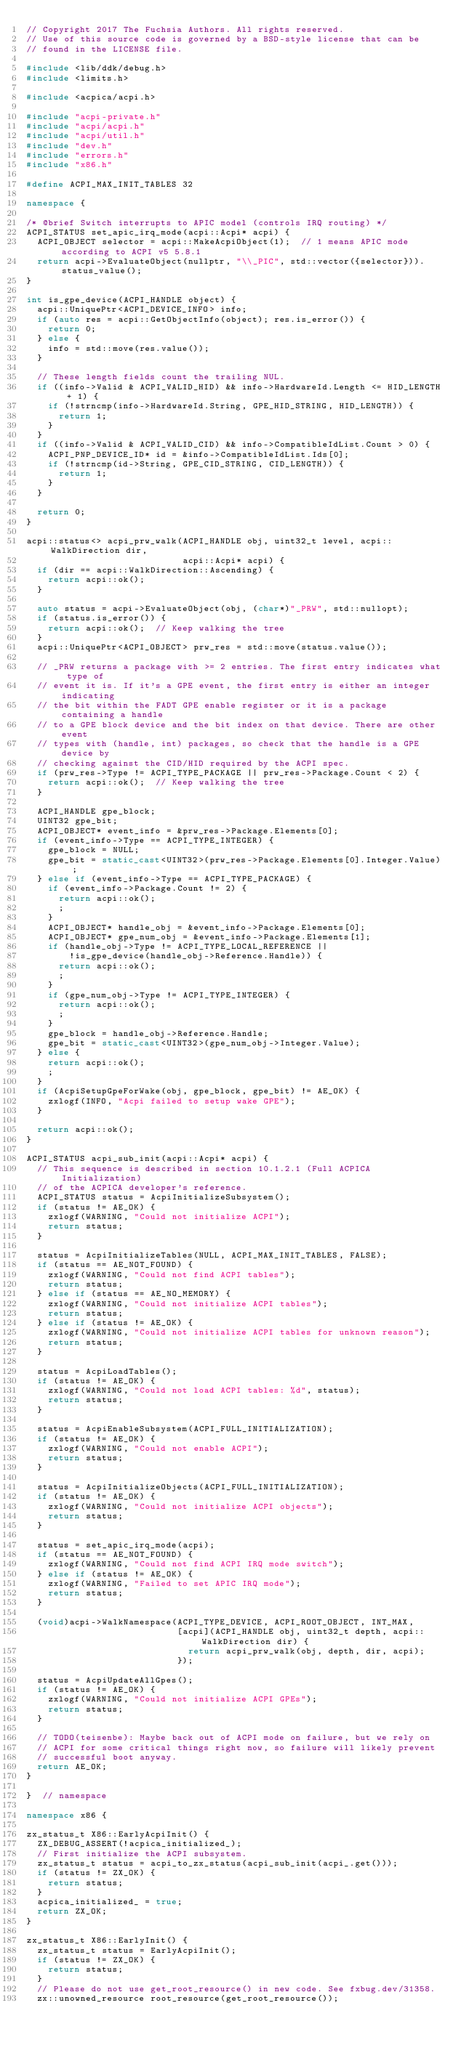Convert code to text. <code><loc_0><loc_0><loc_500><loc_500><_C++_>// Copyright 2017 The Fuchsia Authors. All rights reserved.
// Use of this source code is governed by a BSD-style license that can be
// found in the LICENSE file.

#include <lib/ddk/debug.h>
#include <limits.h>

#include <acpica/acpi.h>

#include "acpi-private.h"
#include "acpi/acpi.h"
#include "acpi/util.h"
#include "dev.h"
#include "errors.h"
#include "x86.h"

#define ACPI_MAX_INIT_TABLES 32

namespace {

/* @brief Switch interrupts to APIC model (controls IRQ routing) */
ACPI_STATUS set_apic_irq_mode(acpi::Acpi* acpi) {
  ACPI_OBJECT selector = acpi::MakeAcpiObject(1);  // 1 means APIC mode according to ACPI v5 5.8.1
  return acpi->EvaluateObject(nullptr, "\\_PIC", std::vector({selector})).status_value();
}

int is_gpe_device(ACPI_HANDLE object) {
  acpi::UniquePtr<ACPI_DEVICE_INFO> info;
  if (auto res = acpi::GetObjectInfo(object); res.is_error()) {
    return 0;
  } else {
    info = std::move(res.value());
  }

  // These length fields count the trailing NUL.
  if ((info->Valid & ACPI_VALID_HID) && info->HardwareId.Length <= HID_LENGTH + 1) {
    if (!strncmp(info->HardwareId.String, GPE_HID_STRING, HID_LENGTH)) {
      return 1;
    }
  }
  if ((info->Valid & ACPI_VALID_CID) && info->CompatibleIdList.Count > 0) {
    ACPI_PNP_DEVICE_ID* id = &info->CompatibleIdList.Ids[0];
    if (!strncmp(id->String, GPE_CID_STRING, CID_LENGTH)) {
      return 1;
    }
  }

  return 0;
}

acpi::status<> acpi_prw_walk(ACPI_HANDLE obj, uint32_t level, acpi::WalkDirection dir,
                             acpi::Acpi* acpi) {
  if (dir == acpi::WalkDirection::Ascending) {
    return acpi::ok();
  }

  auto status = acpi->EvaluateObject(obj, (char*)"_PRW", std::nullopt);
  if (status.is_error()) {
    return acpi::ok();  // Keep walking the tree
  }
  acpi::UniquePtr<ACPI_OBJECT> prw_res = std::move(status.value());

  // _PRW returns a package with >= 2 entries. The first entry indicates what type of
  // event it is. If it's a GPE event, the first entry is either an integer indicating
  // the bit within the FADT GPE enable register or it is a package containing a handle
  // to a GPE block device and the bit index on that device. There are other event
  // types with (handle, int) packages, so check that the handle is a GPE device by
  // checking against the CID/HID required by the ACPI spec.
  if (prw_res->Type != ACPI_TYPE_PACKAGE || prw_res->Package.Count < 2) {
    return acpi::ok();  // Keep walking the tree
  }

  ACPI_HANDLE gpe_block;
  UINT32 gpe_bit;
  ACPI_OBJECT* event_info = &prw_res->Package.Elements[0];
  if (event_info->Type == ACPI_TYPE_INTEGER) {
    gpe_block = NULL;
    gpe_bit = static_cast<UINT32>(prw_res->Package.Elements[0].Integer.Value);
  } else if (event_info->Type == ACPI_TYPE_PACKAGE) {
    if (event_info->Package.Count != 2) {
      return acpi::ok();
      ;
    }
    ACPI_OBJECT* handle_obj = &event_info->Package.Elements[0];
    ACPI_OBJECT* gpe_num_obj = &event_info->Package.Elements[1];
    if (handle_obj->Type != ACPI_TYPE_LOCAL_REFERENCE ||
        !is_gpe_device(handle_obj->Reference.Handle)) {
      return acpi::ok();
      ;
    }
    if (gpe_num_obj->Type != ACPI_TYPE_INTEGER) {
      return acpi::ok();
      ;
    }
    gpe_block = handle_obj->Reference.Handle;
    gpe_bit = static_cast<UINT32>(gpe_num_obj->Integer.Value);
  } else {
    return acpi::ok();
    ;
  }
  if (AcpiSetupGpeForWake(obj, gpe_block, gpe_bit) != AE_OK) {
    zxlogf(INFO, "Acpi failed to setup wake GPE");
  }

  return acpi::ok();
}

ACPI_STATUS acpi_sub_init(acpi::Acpi* acpi) {
  // This sequence is described in section 10.1.2.1 (Full ACPICA Initialization)
  // of the ACPICA developer's reference.
  ACPI_STATUS status = AcpiInitializeSubsystem();
  if (status != AE_OK) {
    zxlogf(WARNING, "Could not initialize ACPI");
    return status;
  }

  status = AcpiInitializeTables(NULL, ACPI_MAX_INIT_TABLES, FALSE);
  if (status == AE_NOT_FOUND) {
    zxlogf(WARNING, "Could not find ACPI tables");
    return status;
  } else if (status == AE_NO_MEMORY) {
    zxlogf(WARNING, "Could not initialize ACPI tables");
    return status;
  } else if (status != AE_OK) {
    zxlogf(WARNING, "Could not initialize ACPI tables for unknown reason");
    return status;
  }

  status = AcpiLoadTables();
  if (status != AE_OK) {
    zxlogf(WARNING, "Could not load ACPI tables: %d", status);
    return status;
  }

  status = AcpiEnableSubsystem(ACPI_FULL_INITIALIZATION);
  if (status != AE_OK) {
    zxlogf(WARNING, "Could not enable ACPI");
    return status;
  }

  status = AcpiInitializeObjects(ACPI_FULL_INITIALIZATION);
  if (status != AE_OK) {
    zxlogf(WARNING, "Could not initialize ACPI objects");
    return status;
  }

  status = set_apic_irq_mode(acpi);
  if (status == AE_NOT_FOUND) {
    zxlogf(WARNING, "Could not find ACPI IRQ mode switch");
  } else if (status != AE_OK) {
    zxlogf(WARNING, "Failed to set APIC IRQ mode");
    return status;
  }

  (void)acpi->WalkNamespace(ACPI_TYPE_DEVICE, ACPI_ROOT_OBJECT, INT_MAX,
                            [acpi](ACPI_HANDLE obj, uint32_t depth, acpi::WalkDirection dir) {
                              return acpi_prw_walk(obj, depth, dir, acpi);
                            });

  status = AcpiUpdateAllGpes();
  if (status != AE_OK) {
    zxlogf(WARNING, "Could not initialize ACPI GPEs");
    return status;
  }

  // TODO(teisenbe): Maybe back out of ACPI mode on failure, but we rely on
  // ACPI for some critical things right now, so failure will likely prevent
  // successful boot anyway.
  return AE_OK;
}

}  // namespace

namespace x86 {

zx_status_t X86::EarlyAcpiInit() {
  ZX_DEBUG_ASSERT(!acpica_initialized_);
  // First initialize the ACPI subsystem.
  zx_status_t status = acpi_to_zx_status(acpi_sub_init(acpi_.get()));
  if (status != ZX_OK) {
    return status;
  }
  acpica_initialized_ = true;
  return ZX_OK;
}

zx_status_t X86::EarlyInit() {
  zx_status_t status = EarlyAcpiInit();
  if (status != ZX_OK) {
    return status;
  }
  // Please do not use get_root_resource() in new code. See fxbug.dev/31358.
  zx::unowned_resource root_resource(get_root_resource());</code> 